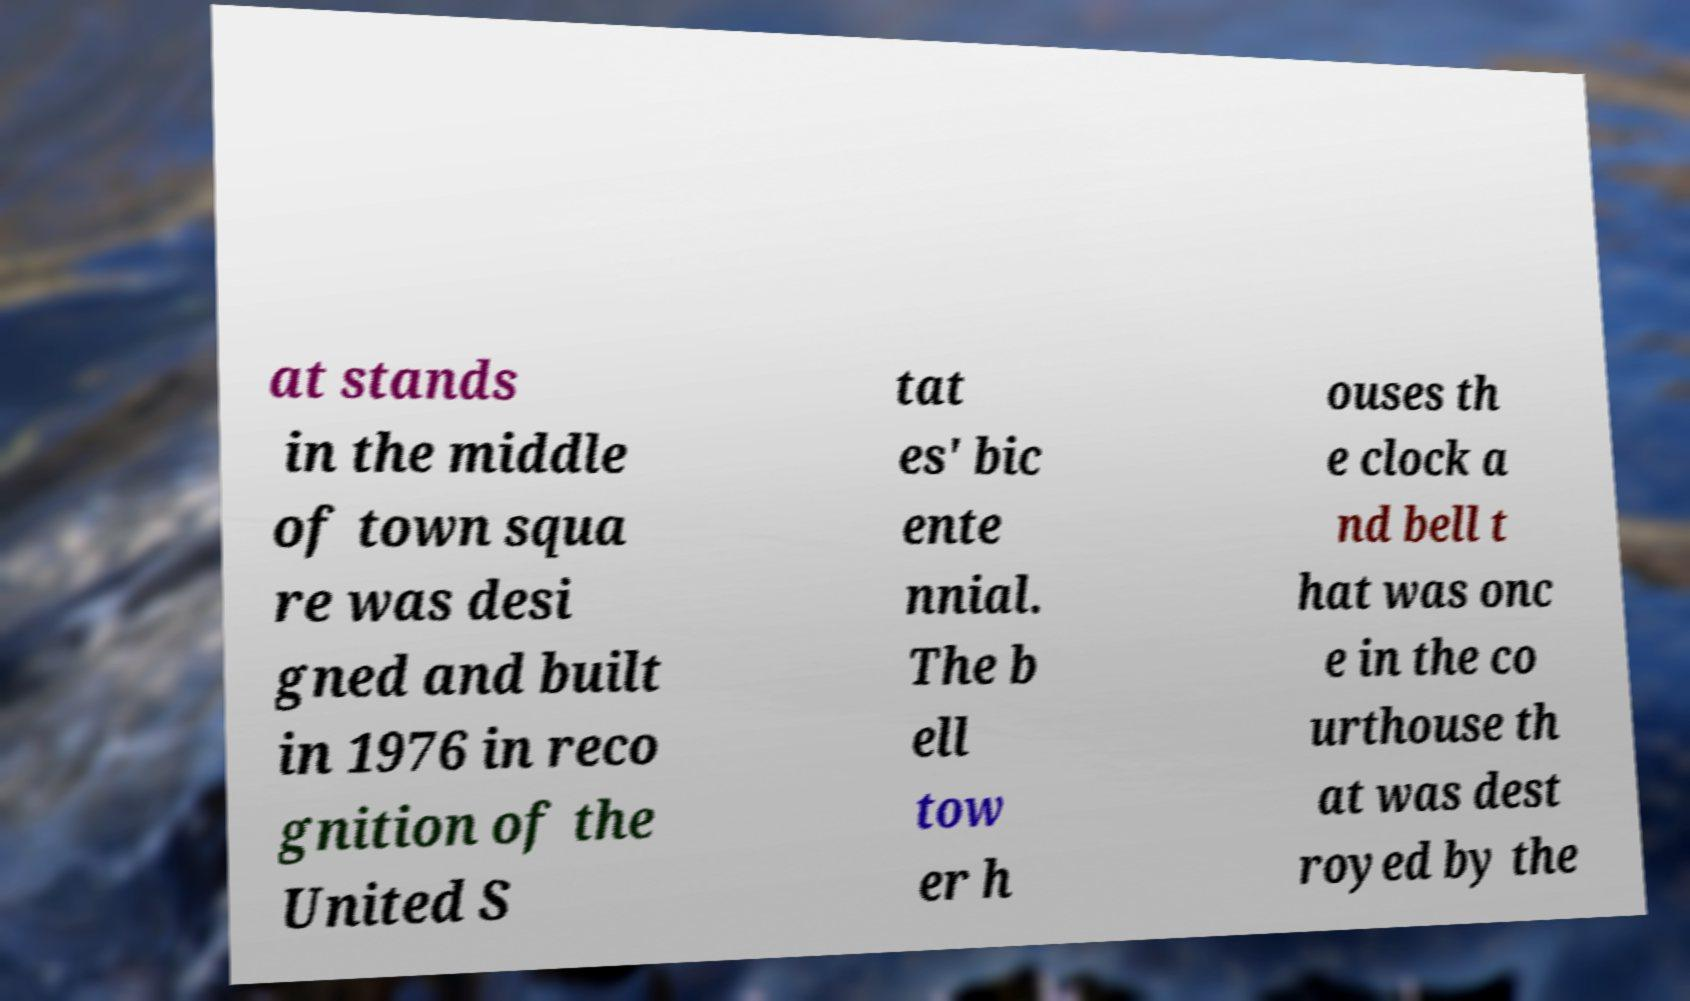What messages or text are displayed in this image? I need them in a readable, typed format. at stands in the middle of town squa re was desi gned and built in 1976 in reco gnition of the United S tat es' bic ente nnial. The b ell tow er h ouses th e clock a nd bell t hat was onc e in the co urthouse th at was dest royed by the 